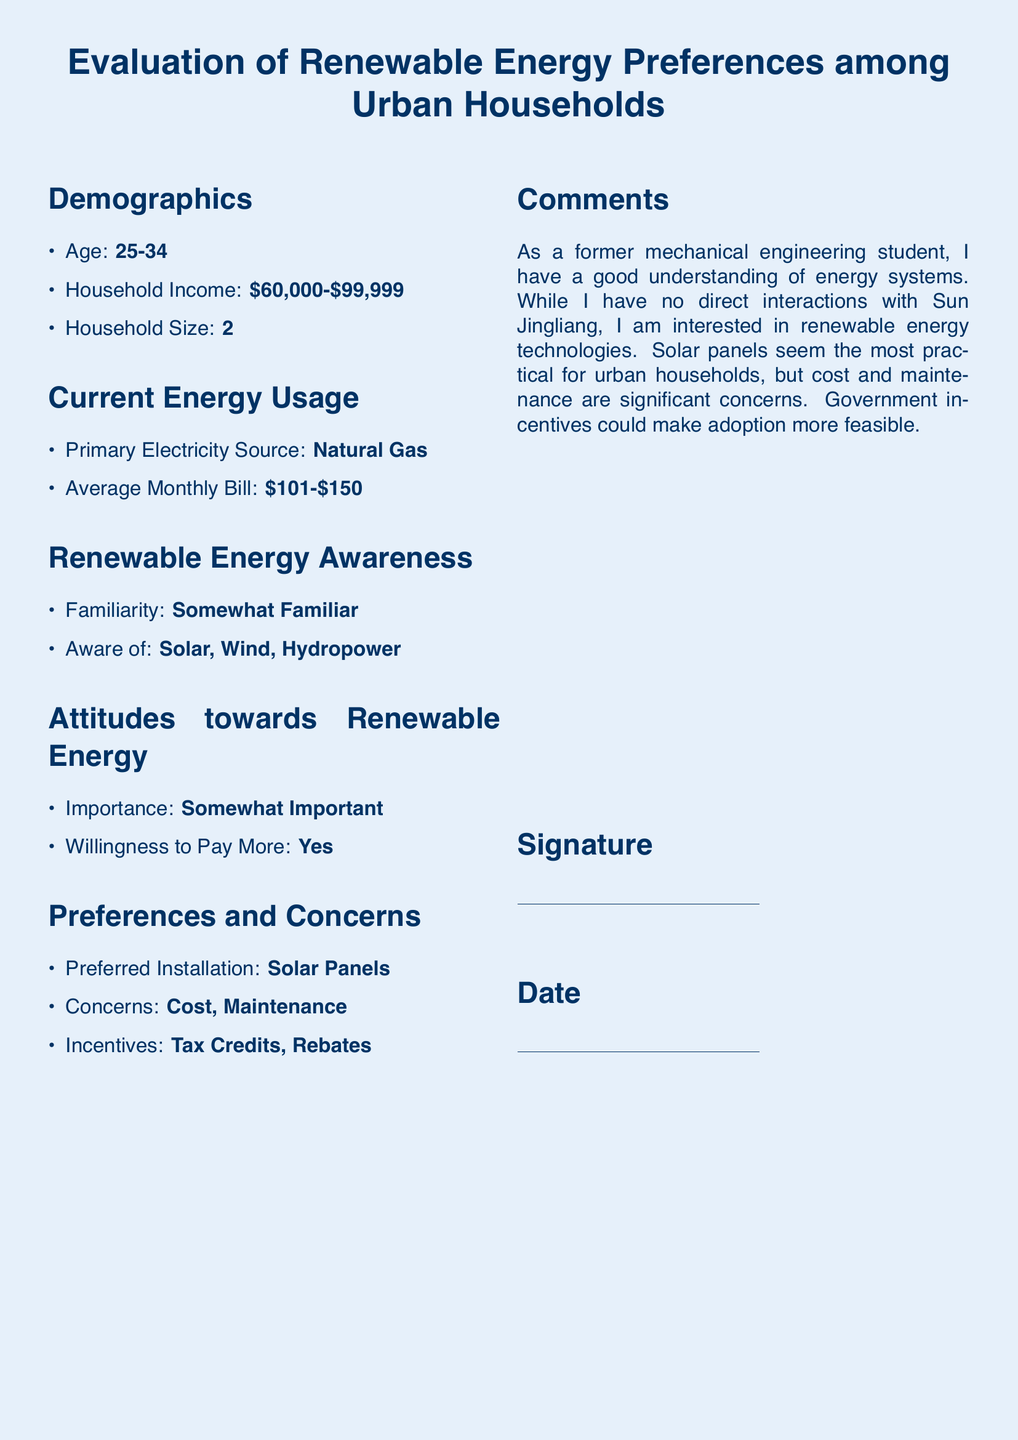What is the age range of the respondents? The age range is stated in the demographics section of the document.
Answer: 25-34 What is the household income range reported? The household income range is listed under demographics.
Answer: $60,000-$99,999 What is the primary electricity source used by the respondents? The primary electricity source is mentioned in the current energy usage section.
Answer: Natural Gas How much is the average monthly electricity bill? The average monthly bill is indicated in the current energy usage section.
Answer: $101-$150 How familiar are the respondents with renewable energy? Familiarity is noted in the renewable energy awareness section.
Answer: Somewhat Familiar What type of renewable energy installation do the respondents prefer? The preferred installation is stated in the preferences and concerns section.
Answer: Solar Panels What concerns do the respondents have about renewable energy? Concerns are listed in the preferences and concerns section.
Answer: Cost, Maintenance Which incentives do respondents believe could promote adoption of renewable energy? Incentives are listed in the preferences and concerns section.
Answer: Tax Credits, Rebates What is the respondents' attitude towards the importance of renewable energy? Importance is expressed in the attitudes towards renewable energy section.
Answer: Somewhat Important 